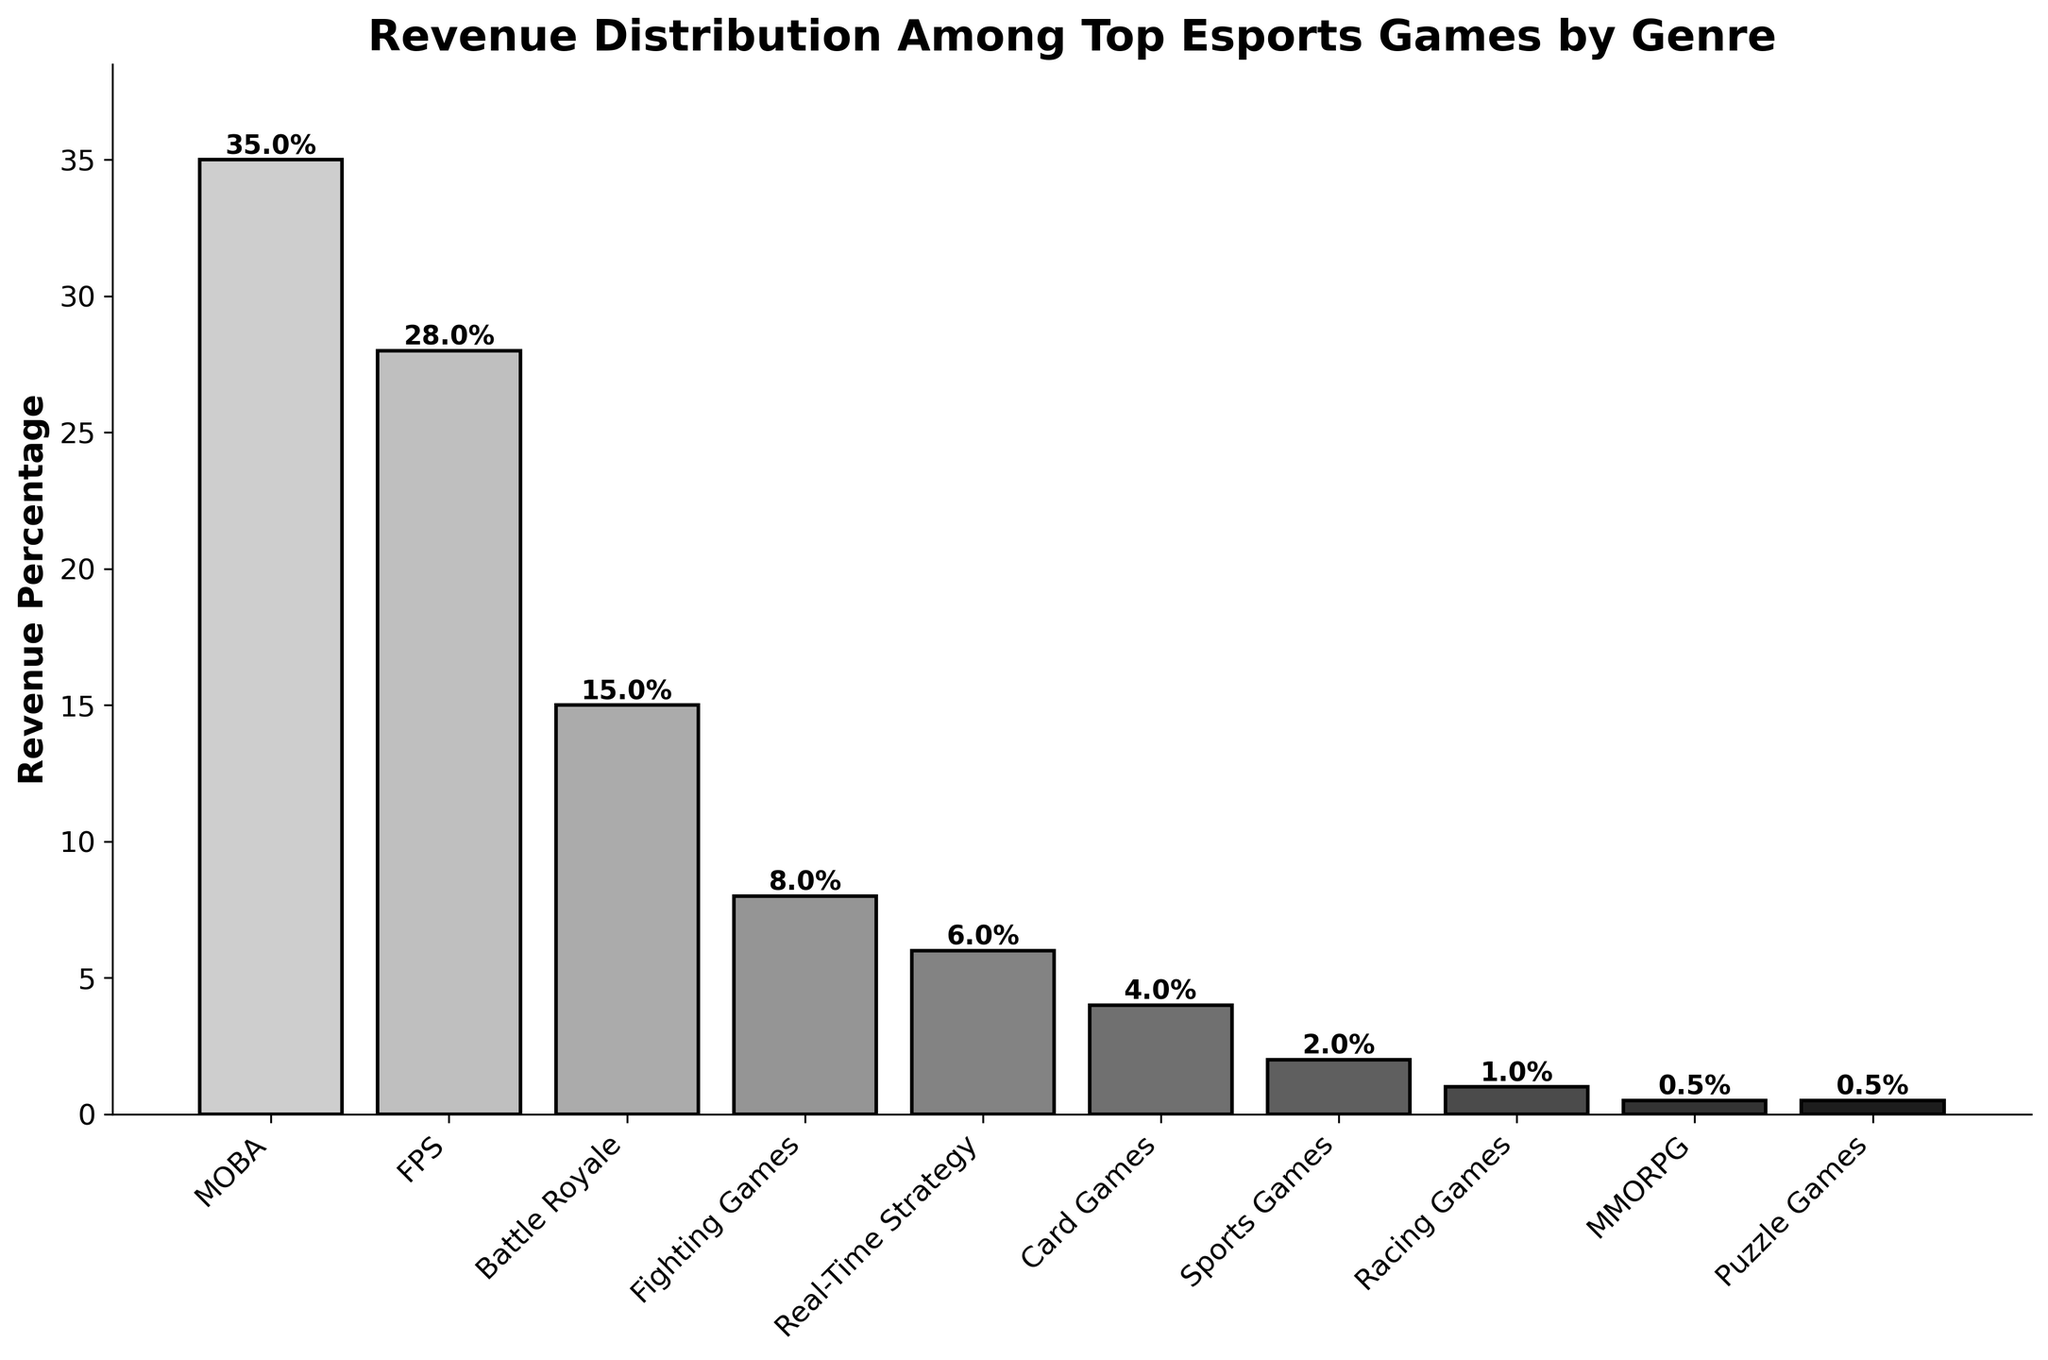Which genre contributes the highest revenue percentage? Look at all the bars and identify the tallest one; the tallest bar represents MOBA with the highest revenue percentage.
Answer: MOBA What's the difference in revenue percentage between FPS and Battle Royale genres? Check the heights of the FPS and Battle Royale bars, subtract the percentage of Battle Royale from FPS (28% - 15%).
Answer: 13% Which genre has the smallest revenue contribution? Identify the shortest bars to find the genres with the smallest revenue percentages, which are MMORPG and Puzzle Games.
Answer: MMORPG and Puzzle Games What percentage revenue do multiplayer online battle arena (MOBA) games contribute? Look at the bar labeled 'MOBA' and read the revenue percentage displayed.
Answer: 35% How much more percentage revenue do MOBA games generate compared to Sports Games? Subtract the percentage of Sports Games from that of MOBA (35% - 2%).
Answer: 33% What is the combined revenue percentage for Real-Time Strategy, Card Games, and Fighting Games? Sum the revenue percentages of the three genres: 6% (Real-Time Strategy) + 4% (Card Games) + 8% (Fighting Games).
Answer: 18% Which genre contributes more revenue: Racing Games or Puzzle Games? Compare the height of the Racing Games bar to that of the Puzzle Games bar; Racing Games is taller.
Answer: Racing Games Rank the top three genres by revenue percentage. Look at all the bars and identify the top three highest: MOBA (35%), FPS (28%), and Battle Royale (15%).
Answer: 1. MOBA, 2. FPS, 3. Battle Royale How much percentage higher is the revenue from MOBA games compared to Real-Time Strategy games? Subtract the percentage of Real-Time Strategy from MOBA (35% - 6%).
Answer: 29% What is the average revenue percentage of the top four genres? Sum the revenue percentages of the top four genres and divide by 4: (35% + 28% + 15% + 8%) / 4 = 86% / 4.
Answer: 21.5% 